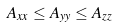<formula> <loc_0><loc_0><loc_500><loc_500>A _ { x x } \leq A _ { y y } \leq A _ { z z }</formula> 